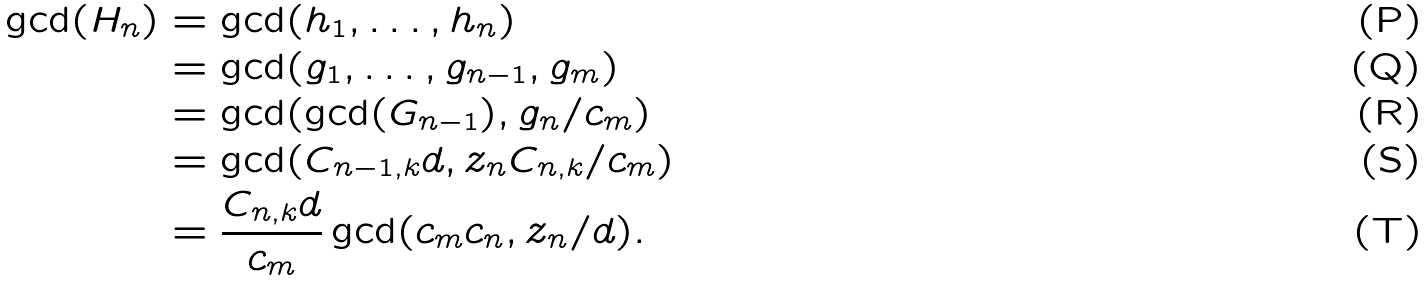<formula> <loc_0><loc_0><loc_500><loc_500>\gcd ( H _ { n } ) & = \gcd ( h _ { 1 } , \dots , h _ { n } ) \\ & = \gcd ( g _ { 1 } , \dots , g _ { n - 1 } , g _ { m } ) \\ & = \gcd ( \gcd ( G _ { n - 1 } ) , g _ { n } / c _ { m } ) \\ & = \gcd ( C _ { n - 1 , k } d , z _ { n } C _ { n , k } / c _ { m } ) \\ & = \frac { C _ { n , k } d } { c _ { m } } \gcd ( c _ { m } c _ { n } , z _ { n } / d ) .</formula> 